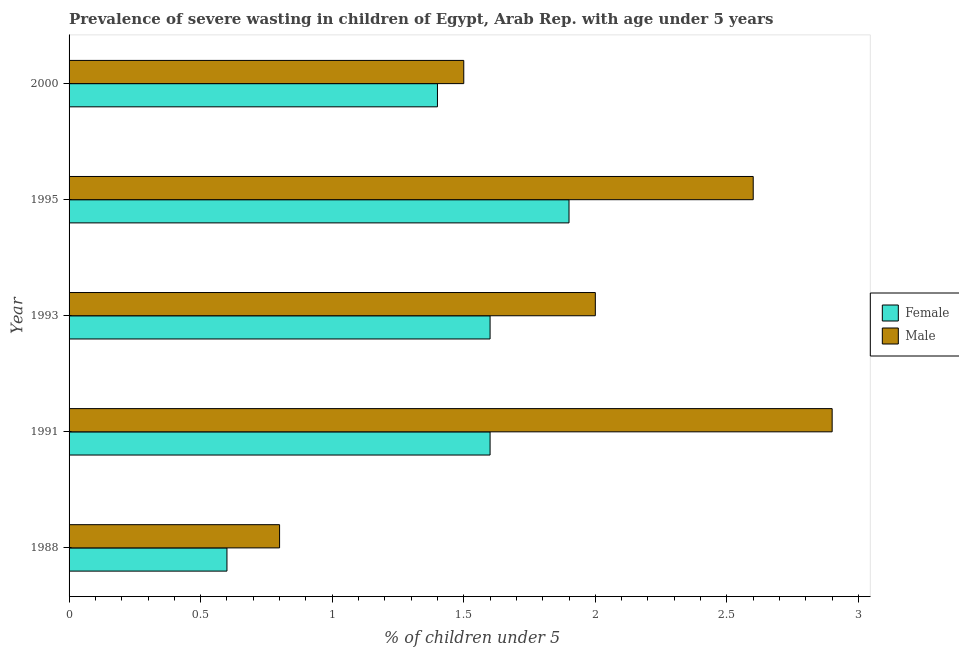How many different coloured bars are there?
Ensure brevity in your answer.  2. In how many cases, is the number of bars for a given year not equal to the number of legend labels?
Offer a terse response. 0. What is the percentage of undernourished male children in 1995?
Your answer should be very brief. 2.6. Across all years, what is the maximum percentage of undernourished male children?
Your answer should be compact. 2.9. Across all years, what is the minimum percentage of undernourished male children?
Give a very brief answer. 0.8. In which year was the percentage of undernourished female children minimum?
Make the answer very short. 1988. What is the total percentage of undernourished female children in the graph?
Your answer should be compact. 7.1. What is the difference between the percentage of undernourished female children in 2000 and the percentage of undernourished male children in 1988?
Offer a terse response. 0.6. What is the average percentage of undernourished female children per year?
Your answer should be very brief. 1.42. In the year 2000, what is the difference between the percentage of undernourished male children and percentage of undernourished female children?
Your answer should be compact. 0.1. What is the ratio of the percentage of undernourished male children in 1993 to that in 2000?
Ensure brevity in your answer.  1.33. Is the percentage of undernourished female children in 1995 less than that in 2000?
Your answer should be compact. No. What is the difference between the highest and the second highest percentage of undernourished female children?
Ensure brevity in your answer.  0.3. What is the difference between the highest and the lowest percentage of undernourished female children?
Keep it short and to the point. 1.3. Are all the bars in the graph horizontal?
Your response must be concise. Yes. How many years are there in the graph?
Your answer should be very brief. 5. Are the values on the major ticks of X-axis written in scientific E-notation?
Provide a short and direct response. No. Where does the legend appear in the graph?
Offer a very short reply. Center right. How many legend labels are there?
Provide a short and direct response. 2. What is the title of the graph?
Provide a short and direct response. Prevalence of severe wasting in children of Egypt, Arab Rep. with age under 5 years. What is the label or title of the X-axis?
Keep it short and to the point.  % of children under 5. What is the label or title of the Y-axis?
Keep it short and to the point. Year. What is the  % of children under 5 of Female in 1988?
Provide a succinct answer. 0.6. What is the  % of children under 5 in Male in 1988?
Your answer should be very brief. 0.8. What is the  % of children under 5 in Female in 1991?
Your answer should be very brief. 1.6. What is the  % of children under 5 of Male in 1991?
Offer a terse response. 2.9. What is the  % of children under 5 of Female in 1993?
Ensure brevity in your answer.  1.6. What is the  % of children under 5 of Female in 1995?
Provide a succinct answer. 1.9. What is the  % of children under 5 of Male in 1995?
Your response must be concise. 2.6. What is the  % of children under 5 in Female in 2000?
Your answer should be compact. 1.4. What is the  % of children under 5 of Male in 2000?
Provide a short and direct response. 1.5. Across all years, what is the maximum  % of children under 5 in Female?
Keep it short and to the point. 1.9. Across all years, what is the maximum  % of children under 5 of Male?
Give a very brief answer. 2.9. Across all years, what is the minimum  % of children under 5 in Female?
Provide a succinct answer. 0.6. Across all years, what is the minimum  % of children under 5 in Male?
Your answer should be compact. 0.8. What is the total  % of children under 5 in Male in the graph?
Make the answer very short. 9.8. What is the difference between the  % of children under 5 of Male in 1988 and that in 1993?
Your answer should be compact. -1.2. What is the difference between the  % of children under 5 in Female in 1988 and that in 1995?
Keep it short and to the point. -1.3. What is the difference between the  % of children under 5 of Male in 1988 and that in 1995?
Your answer should be very brief. -1.8. What is the difference between the  % of children under 5 in Female in 1988 and that in 2000?
Your response must be concise. -0.8. What is the difference between the  % of children under 5 of Male in 1991 and that in 1993?
Offer a very short reply. 0.9. What is the difference between the  % of children under 5 of Female in 1991 and that in 2000?
Your answer should be compact. 0.2. What is the difference between the  % of children under 5 in Male in 1991 and that in 2000?
Give a very brief answer. 1.4. What is the difference between the  % of children under 5 of Female in 1993 and that in 1995?
Give a very brief answer. -0.3. What is the difference between the  % of children under 5 in Male in 1993 and that in 2000?
Provide a succinct answer. 0.5. What is the difference between the  % of children under 5 of Female in 1988 and the  % of children under 5 of Male in 1995?
Make the answer very short. -2. What is the difference between the  % of children under 5 of Female in 1991 and the  % of children under 5 of Male in 1993?
Keep it short and to the point. -0.4. What is the difference between the  % of children under 5 in Female in 1991 and the  % of children under 5 in Male in 2000?
Your response must be concise. 0.1. What is the difference between the  % of children under 5 of Female in 1993 and the  % of children under 5 of Male in 2000?
Offer a terse response. 0.1. What is the difference between the  % of children under 5 of Female in 1995 and the  % of children under 5 of Male in 2000?
Provide a short and direct response. 0.4. What is the average  % of children under 5 of Female per year?
Provide a short and direct response. 1.42. What is the average  % of children under 5 of Male per year?
Offer a very short reply. 1.96. In the year 1991, what is the difference between the  % of children under 5 of Female and  % of children under 5 of Male?
Provide a short and direct response. -1.3. In the year 2000, what is the difference between the  % of children under 5 of Female and  % of children under 5 of Male?
Keep it short and to the point. -0.1. What is the ratio of the  % of children under 5 of Female in 1988 to that in 1991?
Give a very brief answer. 0.38. What is the ratio of the  % of children under 5 in Male in 1988 to that in 1991?
Your response must be concise. 0.28. What is the ratio of the  % of children under 5 of Male in 1988 to that in 1993?
Offer a very short reply. 0.4. What is the ratio of the  % of children under 5 in Female in 1988 to that in 1995?
Provide a succinct answer. 0.32. What is the ratio of the  % of children under 5 of Male in 1988 to that in 1995?
Offer a terse response. 0.31. What is the ratio of the  % of children under 5 of Female in 1988 to that in 2000?
Your response must be concise. 0.43. What is the ratio of the  % of children under 5 in Male in 1988 to that in 2000?
Your answer should be compact. 0.53. What is the ratio of the  % of children under 5 in Male in 1991 to that in 1993?
Make the answer very short. 1.45. What is the ratio of the  % of children under 5 of Female in 1991 to that in 1995?
Your answer should be compact. 0.84. What is the ratio of the  % of children under 5 of Male in 1991 to that in 1995?
Provide a short and direct response. 1.12. What is the ratio of the  % of children under 5 of Female in 1991 to that in 2000?
Keep it short and to the point. 1.14. What is the ratio of the  % of children under 5 in Male in 1991 to that in 2000?
Provide a short and direct response. 1.93. What is the ratio of the  % of children under 5 in Female in 1993 to that in 1995?
Provide a succinct answer. 0.84. What is the ratio of the  % of children under 5 in Male in 1993 to that in 1995?
Ensure brevity in your answer.  0.77. What is the ratio of the  % of children under 5 in Female in 1993 to that in 2000?
Make the answer very short. 1.14. What is the ratio of the  % of children under 5 of Female in 1995 to that in 2000?
Offer a very short reply. 1.36. What is the ratio of the  % of children under 5 of Male in 1995 to that in 2000?
Your answer should be very brief. 1.73. What is the difference between the highest and the second highest  % of children under 5 of Female?
Provide a short and direct response. 0.3. What is the difference between the highest and the lowest  % of children under 5 in Male?
Your response must be concise. 2.1. 